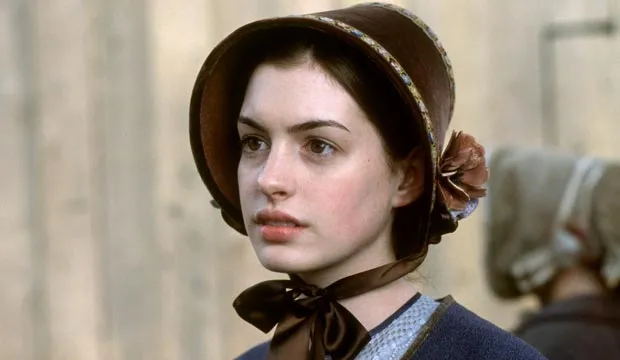What do you think is going on in this snapshot? In this image, there is a woman wearing a period costume, which includes a blue dress and a brown bonnet with a black ribbon tied around her neck. She is standing in front of a wooden wall, looking off to the side with a serious expression. There is another blurred figure in the background, adding depth to the scene. 